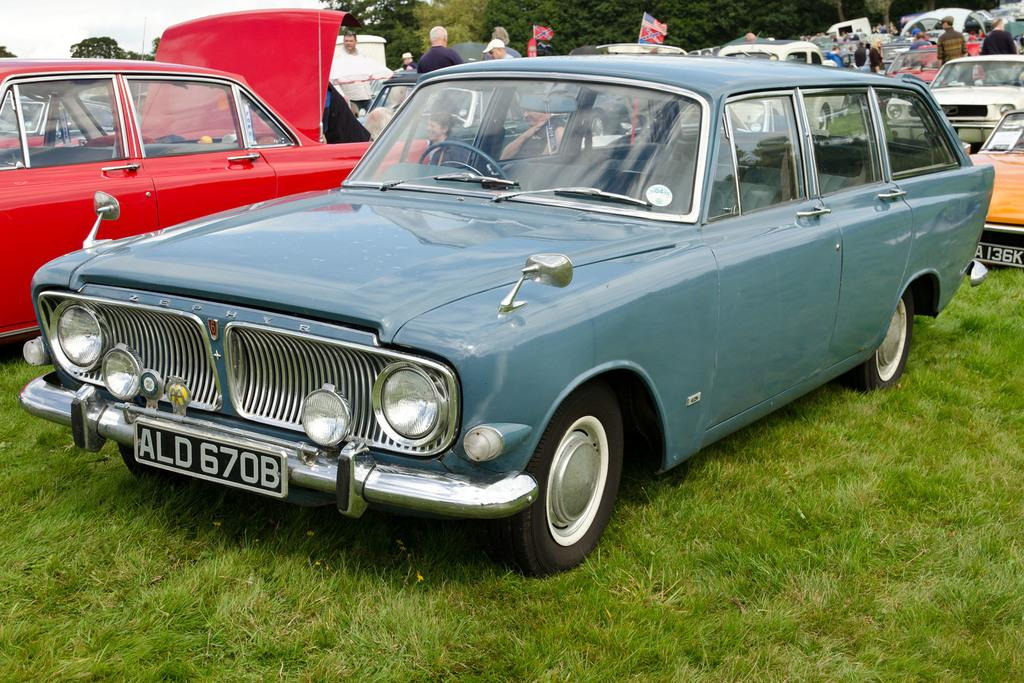What is the main subject in the front of the image? There is a car in the front of the image. What type of terrain is visible in the image? There is grass on the ground. What can be seen in the background of the image? There are cars, persons, flags, and trees in the background of the image. What type of muscle can be seen growing on the car in the image? There is no muscle visible on the car in the image. How many icicles are hanging from the trees in the background of the image? There is no mention of icicles in the image; only trees are mentioned in the background. 